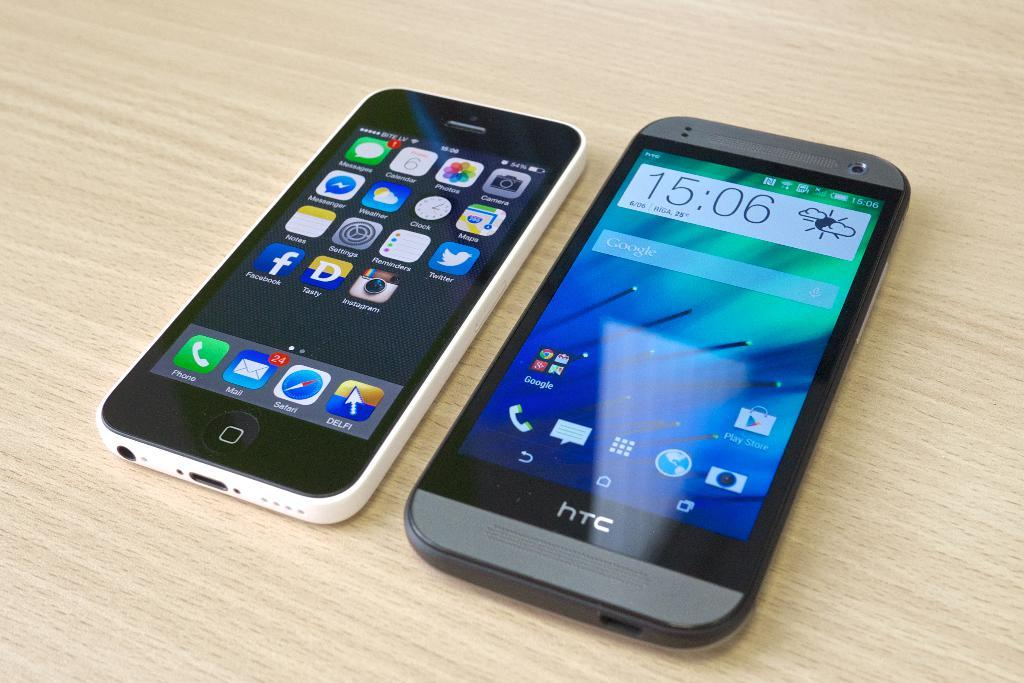<image>
Summarize the visual content of the image. Two phones are sitting next to each other and one of them is a silver or gray HTC. 